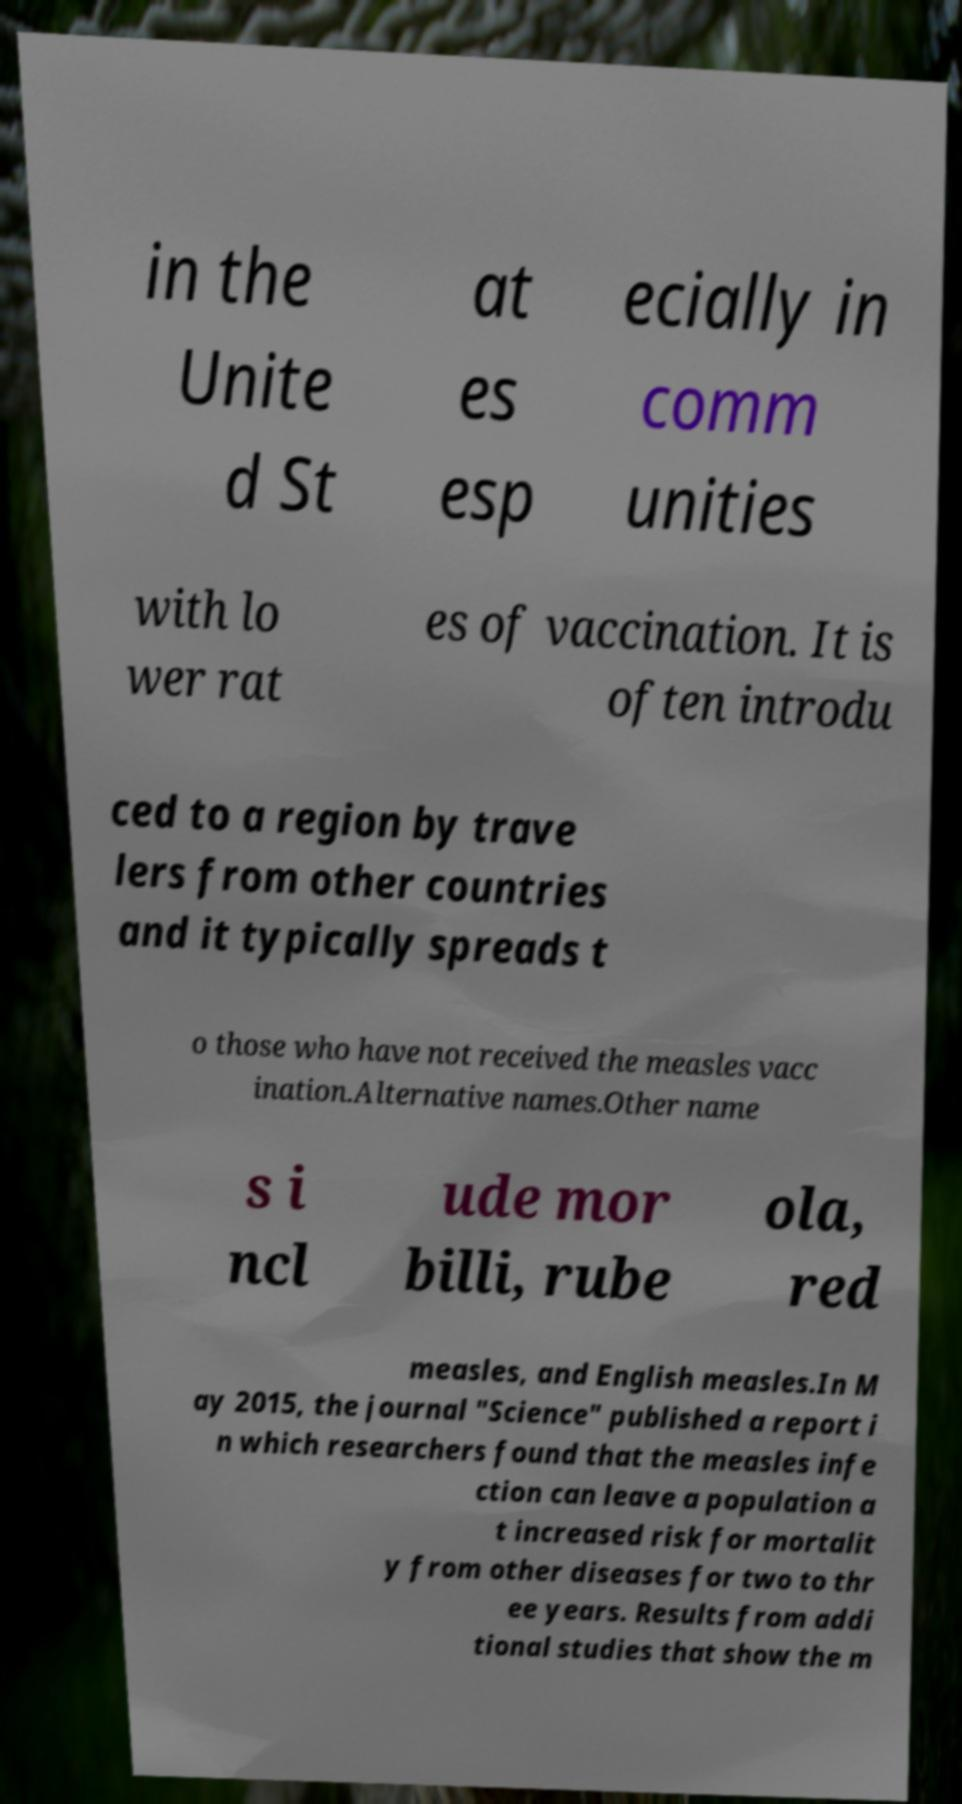Could you extract and type out the text from this image? in the Unite d St at es esp ecially in comm unities with lo wer rat es of vaccination. It is often introdu ced to a region by trave lers from other countries and it typically spreads t o those who have not received the measles vacc ination.Alternative names.Other name s i ncl ude mor billi, rube ola, red measles, and English measles.In M ay 2015, the journal "Science" published a report i n which researchers found that the measles infe ction can leave a population a t increased risk for mortalit y from other diseases for two to thr ee years. Results from addi tional studies that show the m 